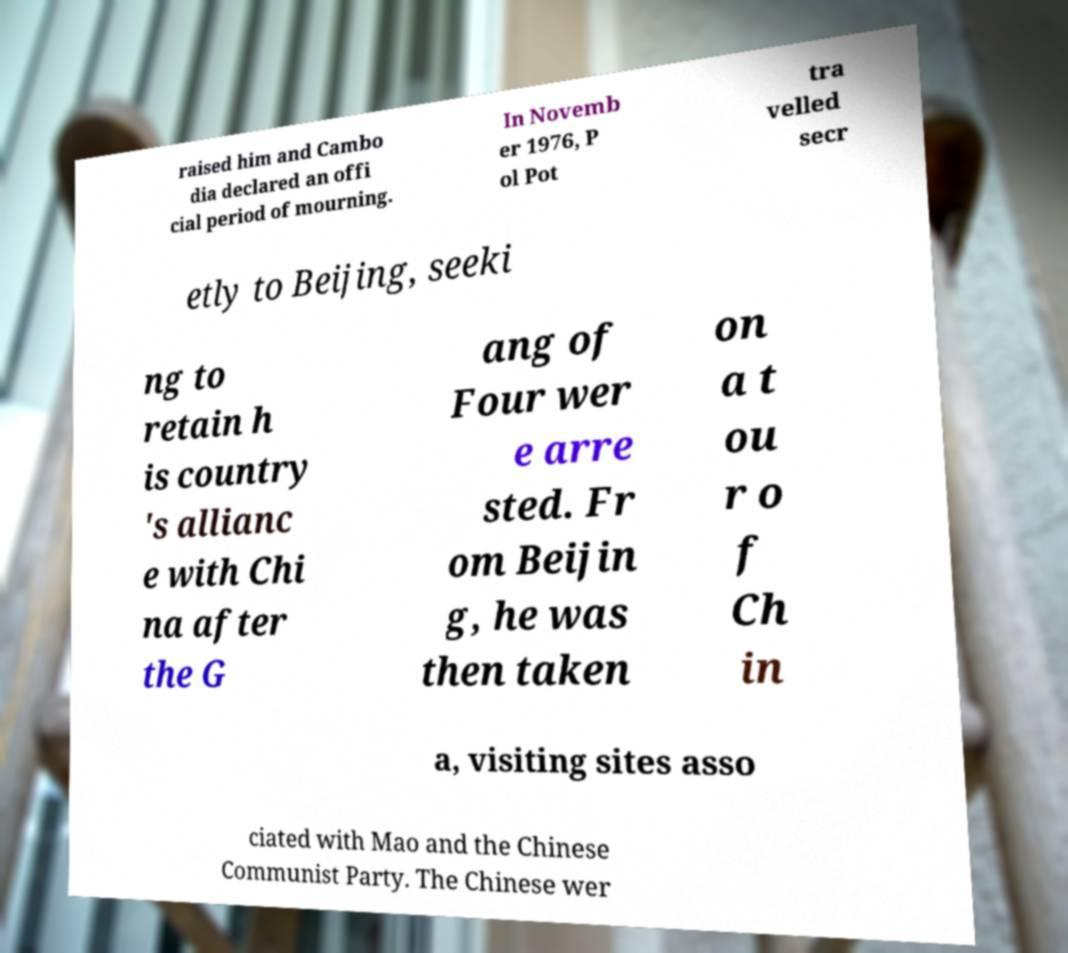There's text embedded in this image that I need extracted. Can you transcribe it verbatim? raised him and Cambo dia declared an offi cial period of mourning. In Novemb er 1976, P ol Pot tra velled secr etly to Beijing, seeki ng to retain h is country 's allianc e with Chi na after the G ang of Four wer e arre sted. Fr om Beijin g, he was then taken on a t ou r o f Ch in a, visiting sites asso ciated with Mao and the Chinese Communist Party. The Chinese wer 